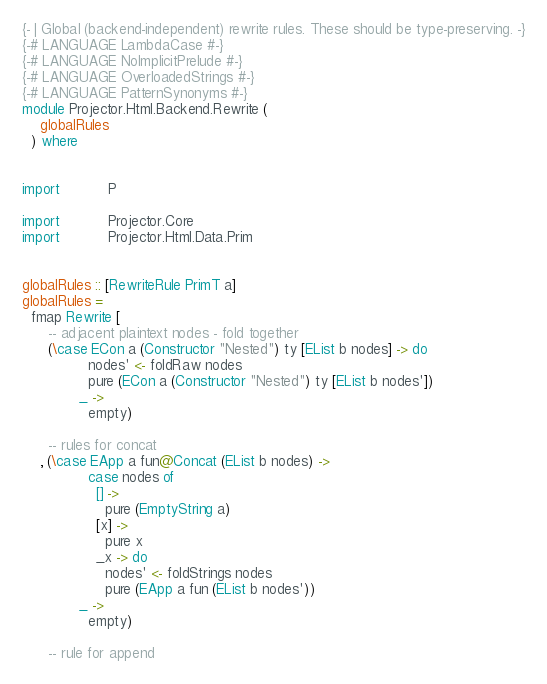<code> <loc_0><loc_0><loc_500><loc_500><_Haskell_>{- | Global (backend-independent) rewrite rules. These should be type-preserving. -}
{-# LANGUAGE LambdaCase #-}
{-# LANGUAGE NoImplicitPrelude #-}
{-# LANGUAGE OverloadedStrings #-}
{-# LANGUAGE PatternSynonyms #-}
module Projector.Html.Backend.Rewrite (
    globalRules
  ) where


import           P

import           Projector.Core
import           Projector.Html.Data.Prim


globalRules :: [RewriteRule PrimT a]
globalRules =
  fmap Rewrite [
      -- adjacent plaintext nodes - fold together
      (\case ECon a (Constructor "Nested") ty [EList b nodes] -> do
               nodes' <- foldRaw nodes
               pure (ECon a (Constructor "Nested") ty [EList b nodes'])
             _ ->
               empty)

      -- rules for concat
    , (\case EApp a fun@Concat (EList b nodes) ->
               case nodes of
                 [] ->
                   pure (EmptyString a)
                 [x] ->
                   pure x
                 _x -> do
                   nodes' <- foldStrings nodes
                   pure (EApp a fun (EList b nodes'))
             _ ->
               empty)

      -- rule for append</code> 